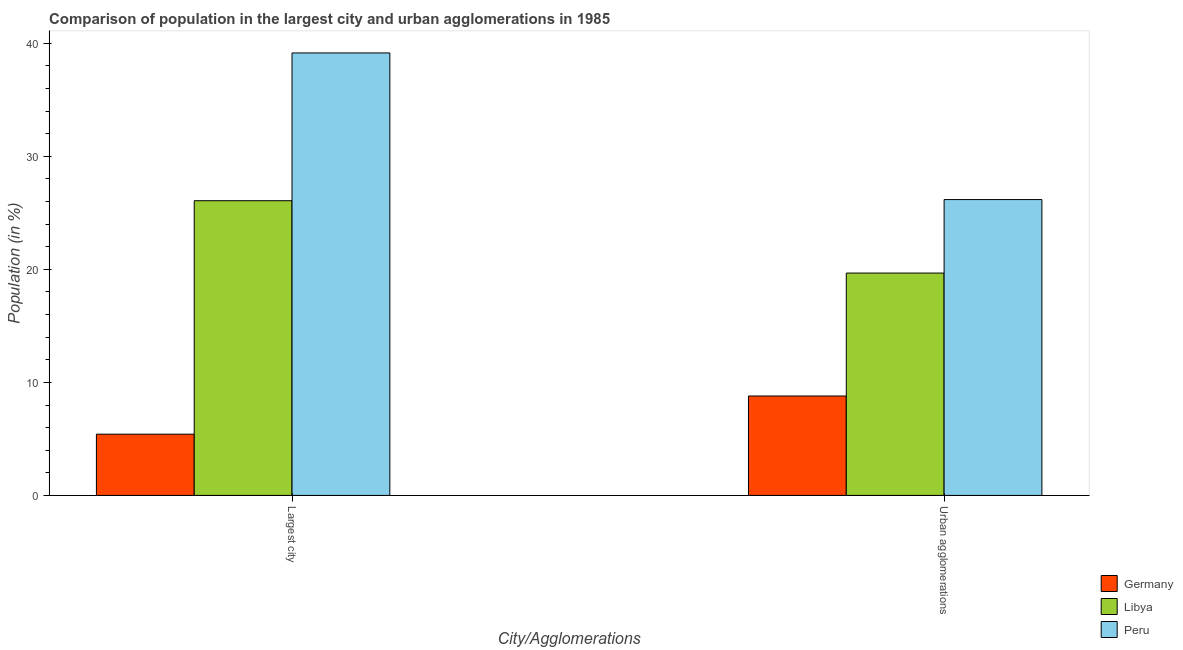Are the number of bars per tick equal to the number of legend labels?
Offer a terse response. Yes. How many bars are there on the 1st tick from the right?
Give a very brief answer. 3. What is the label of the 1st group of bars from the left?
Keep it short and to the point. Largest city. What is the population in the largest city in Libya?
Keep it short and to the point. 26.07. Across all countries, what is the maximum population in the largest city?
Ensure brevity in your answer.  39.15. Across all countries, what is the minimum population in the largest city?
Offer a terse response. 5.42. In which country was the population in the largest city minimum?
Your response must be concise. Germany. What is the total population in urban agglomerations in the graph?
Provide a succinct answer. 54.65. What is the difference between the population in the largest city in Germany and that in Libya?
Your response must be concise. -20.66. What is the difference between the population in urban agglomerations in Peru and the population in the largest city in Libya?
Provide a short and direct response. 0.1. What is the average population in urban agglomerations per country?
Offer a terse response. 18.22. What is the difference between the population in the largest city and population in urban agglomerations in Germany?
Your response must be concise. -3.38. In how many countries, is the population in urban agglomerations greater than 30 %?
Provide a succinct answer. 0. What is the ratio of the population in the largest city in Germany to that in Peru?
Make the answer very short. 0.14. Is the population in the largest city in Libya less than that in Peru?
Your answer should be very brief. Yes. In how many countries, is the population in urban agglomerations greater than the average population in urban agglomerations taken over all countries?
Your response must be concise. 2. What does the 2nd bar from the left in Urban agglomerations represents?
Your answer should be very brief. Libya. What does the 1st bar from the right in Largest city represents?
Your answer should be compact. Peru. How many countries are there in the graph?
Your answer should be compact. 3. What is the difference between two consecutive major ticks on the Y-axis?
Provide a succinct answer. 10. Does the graph contain grids?
Give a very brief answer. No. How many legend labels are there?
Give a very brief answer. 3. What is the title of the graph?
Offer a terse response. Comparison of population in the largest city and urban agglomerations in 1985. Does "Spain" appear as one of the legend labels in the graph?
Keep it short and to the point. No. What is the label or title of the X-axis?
Provide a short and direct response. City/Agglomerations. What is the Population (in %) of Germany in Largest city?
Your response must be concise. 5.42. What is the Population (in %) in Libya in Largest city?
Your response must be concise. 26.07. What is the Population (in %) in Peru in Largest city?
Offer a terse response. 39.15. What is the Population (in %) in Germany in Urban agglomerations?
Provide a short and direct response. 8.8. What is the Population (in %) of Libya in Urban agglomerations?
Provide a succinct answer. 19.67. What is the Population (in %) in Peru in Urban agglomerations?
Your response must be concise. 26.18. Across all City/Agglomerations, what is the maximum Population (in %) of Germany?
Give a very brief answer. 8.8. Across all City/Agglomerations, what is the maximum Population (in %) in Libya?
Make the answer very short. 26.07. Across all City/Agglomerations, what is the maximum Population (in %) in Peru?
Give a very brief answer. 39.15. Across all City/Agglomerations, what is the minimum Population (in %) in Germany?
Offer a terse response. 5.42. Across all City/Agglomerations, what is the minimum Population (in %) in Libya?
Your answer should be very brief. 19.67. Across all City/Agglomerations, what is the minimum Population (in %) in Peru?
Give a very brief answer. 26.18. What is the total Population (in %) of Germany in the graph?
Provide a succinct answer. 14.21. What is the total Population (in %) in Libya in the graph?
Give a very brief answer. 45.75. What is the total Population (in %) of Peru in the graph?
Offer a terse response. 65.32. What is the difference between the Population (in %) in Germany in Largest city and that in Urban agglomerations?
Provide a succinct answer. -3.38. What is the difference between the Population (in %) in Libya in Largest city and that in Urban agglomerations?
Your answer should be compact. 6.4. What is the difference between the Population (in %) in Peru in Largest city and that in Urban agglomerations?
Keep it short and to the point. 12.97. What is the difference between the Population (in %) in Germany in Largest city and the Population (in %) in Libya in Urban agglomerations?
Ensure brevity in your answer.  -14.26. What is the difference between the Population (in %) of Germany in Largest city and the Population (in %) of Peru in Urban agglomerations?
Make the answer very short. -20.76. What is the difference between the Population (in %) of Libya in Largest city and the Population (in %) of Peru in Urban agglomerations?
Your response must be concise. -0.1. What is the average Population (in %) of Germany per City/Agglomerations?
Offer a very short reply. 7.11. What is the average Population (in %) of Libya per City/Agglomerations?
Offer a very short reply. 22.87. What is the average Population (in %) of Peru per City/Agglomerations?
Your answer should be very brief. 32.66. What is the difference between the Population (in %) in Germany and Population (in %) in Libya in Largest city?
Offer a terse response. -20.66. What is the difference between the Population (in %) in Germany and Population (in %) in Peru in Largest city?
Make the answer very short. -33.73. What is the difference between the Population (in %) in Libya and Population (in %) in Peru in Largest city?
Offer a terse response. -13.07. What is the difference between the Population (in %) of Germany and Population (in %) of Libya in Urban agglomerations?
Provide a short and direct response. -10.88. What is the difference between the Population (in %) in Germany and Population (in %) in Peru in Urban agglomerations?
Ensure brevity in your answer.  -17.38. What is the difference between the Population (in %) in Libya and Population (in %) in Peru in Urban agglomerations?
Give a very brief answer. -6.5. What is the ratio of the Population (in %) in Germany in Largest city to that in Urban agglomerations?
Make the answer very short. 0.62. What is the ratio of the Population (in %) of Libya in Largest city to that in Urban agglomerations?
Ensure brevity in your answer.  1.33. What is the ratio of the Population (in %) of Peru in Largest city to that in Urban agglomerations?
Your answer should be very brief. 1.5. What is the difference between the highest and the second highest Population (in %) in Germany?
Give a very brief answer. 3.38. What is the difference between the highest and the second highest Population (in %) in Libya?
Provide a succinct answer. 6.4. What is the difference between the highest and the second highest Population (in %) of Peru?
Keep it short and to the point. 12.97. What is the difference between the highest and the lowest Population (in %) of Germany?
Offer a terse response. 3.38. What is the difference between the highest and the lowest Population (in %) of Libya?
Offer a very short reply. 6.4. What is the difference between the highest and the lowest Population (in %) in Peru?
Ensure brevity in your answer.  12.97. 